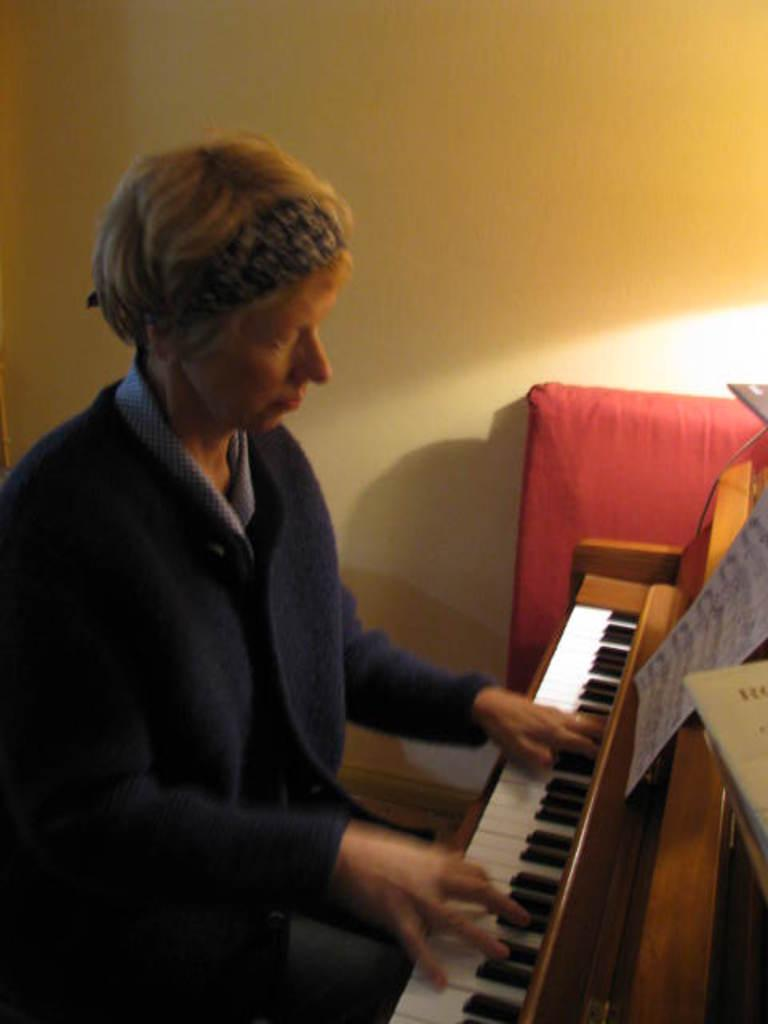What is the person in the image doing? The person is playing a piano. What object is present in the image besides the piano? There is a paper in the image. What can be seen in the background of the image? There is a wall in the background of the image. Is the person in the image a spy, and what division do they belong to? There is no indication in the image that the person is a spy or belongs to any division. 